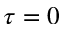<formula> <loc_0><loc_0><loc_500><loc_500>\tau = 0</formula> 